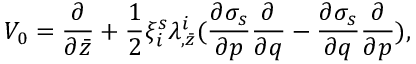<formula> <loc_0><loc_0><loc_500><loc_500>V _ { 0 } = { \frac { \partial } { \partial \bar { z } } } + { \frac { 1 } { 2 } } \xi _ { i } ^ { s } \lambda _ { , \bar { z } } ^ { i } ( { \frac { \partial \sigma _ { s } } { \partial p } } { \frac { \partial } { \partial q } } - { \frac { \partial \sigma _ { s } } { \partial q } } { \frac { \partial } { \partial p } } ) ,</formula> 